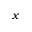Convert formula to latex. <formula><loc_0><loc_0><loc_500><loc_500>x</formula> 